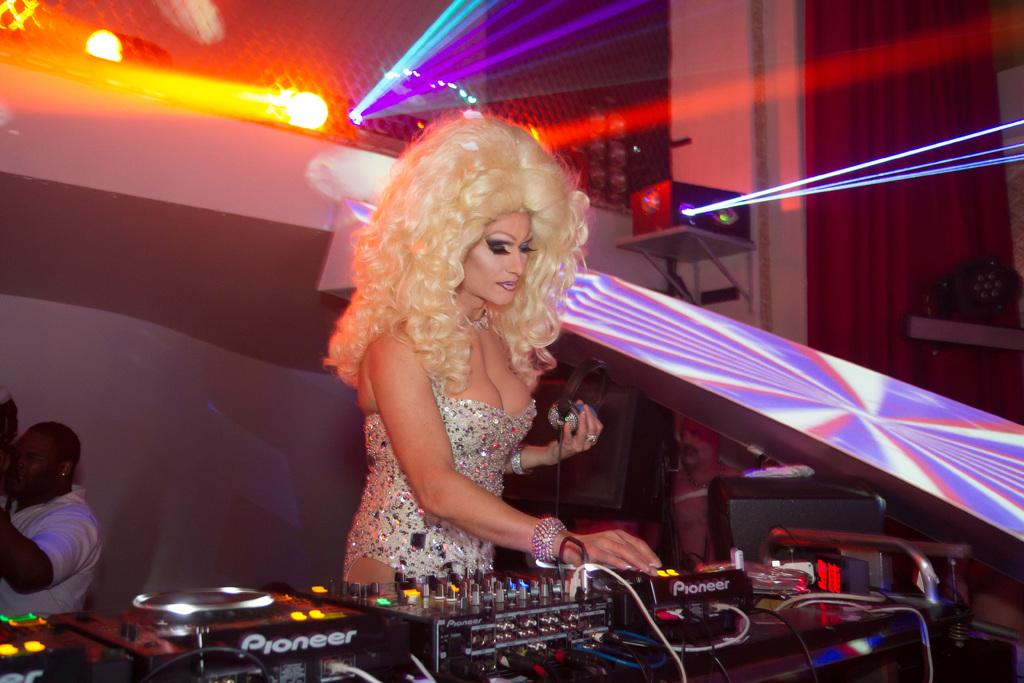Who is the main subject in the image? There is a woman at the center of the image. What is located at the bottom of the image? There are music control instruments at the bottom of the image. Can you describe the person on the left side of the image? There is a man on the left side of the image. What can be seen at the top of the image? There are lights at the top of the image. What type of sleet is falling in the image? There is no sleet present in the image. What songs are being played by the music control instruments in the image? The provided facts do not mention any specific songs being played by the music control instruments. 